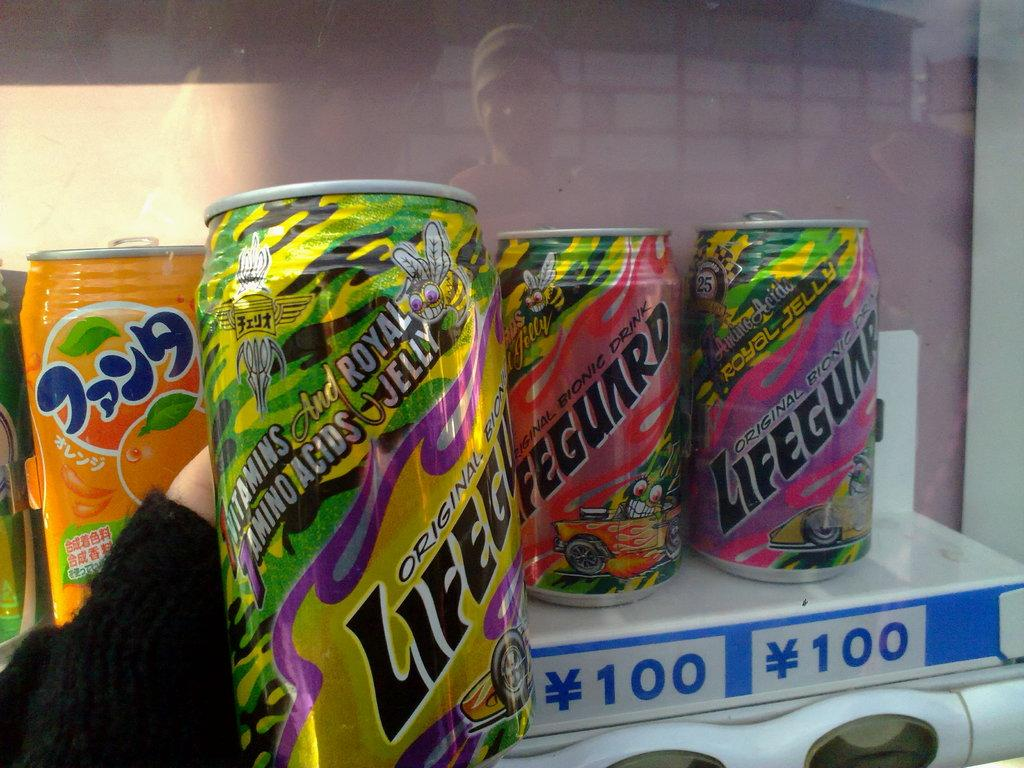Provide a one-sentence caption for the provided image. Three beverage cans that have Lifegunrd written on them. 